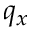<formula> <loc_0><loc_0><loc_500><loc_500>q _ { x }</formula> 